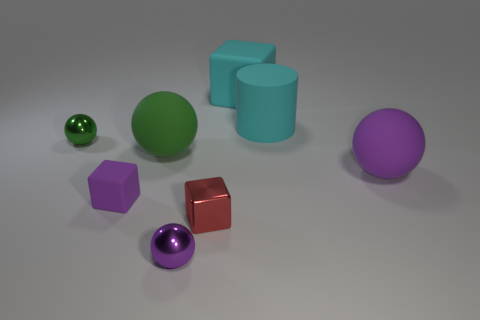Add 1 small purple objects. How many objects exist? 9 Subtract all purple rubber balls. How many balls are left? 3 Subtract all red blocks. How many blocks are left? 2 Subtract all cylinders. How many objects are left? 7 Subtract 3 spheres. How many spheres are left? 1 Subtract all gray blocks. Subtract all purple balls. How many blocks are left? 3 Subtract all red blocks. How many purple balls are left? 2 Subtract all shiny objects. Subtract all purple spheres. How many objects are left? 3 Add 6 metal balls. How many metal balls are left? 8 Add 8 large red matte balls. How many large red matte balls exist? 8 